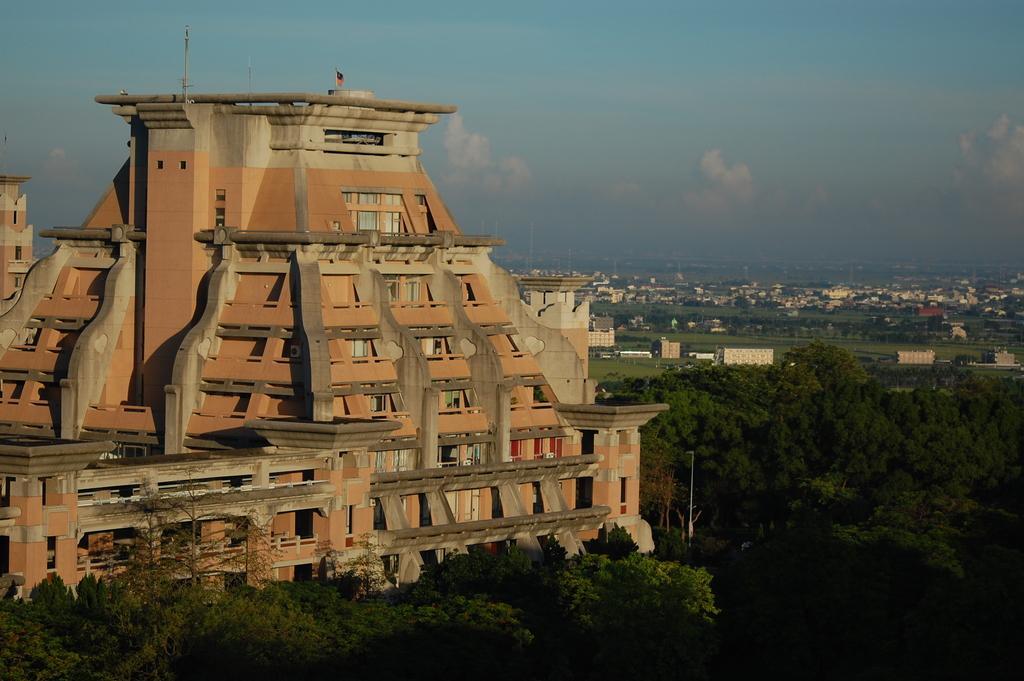Could you give a brief overview of what you see in this image? In this picture, we can see a few building with windows, poles, a flag, trees and the sky with clouds. 